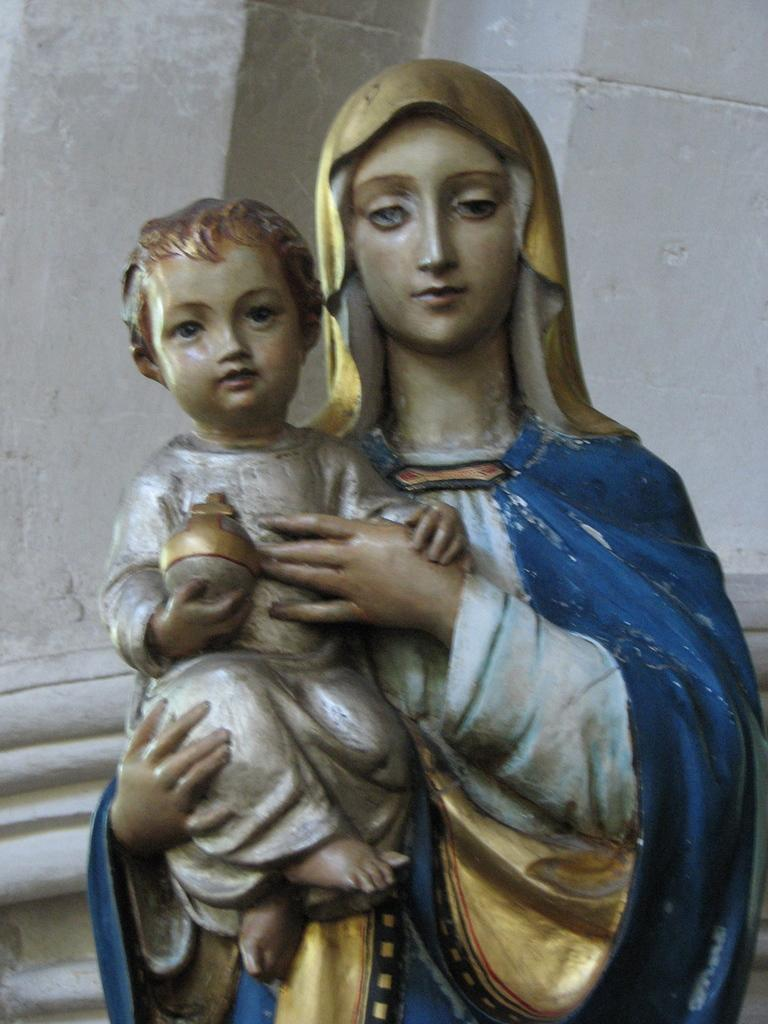What is the main subject of the image? There is a statue of a woman in the image. What is the woman holding in her hand? The woman is holding a boy in her hand. What is the boy holding in his hand? The boy is holding a toy in his hand. What can be seen in the background of the image? There is a wall visible in the background of the image. How many sinks are visible in the image? There are no sinks present in the image. What type of sack is the woman carrying in the image? The woman is a statue and is not carrying a sack in the image. 